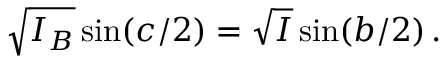Convert formula to latex. <formula><loc_0><loc_0><loc_500><loc_500>\sqrt { I _ { B } } \sin ( c / 2 ) = \sqrt { I } \sin ( b / 2 ) \, .</formula> 